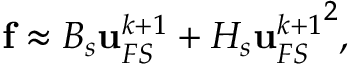Convert formula to latex. <formula><loc_0><loc_0><loc_500><loc_500>f \approx B _ { s } u _ { F S } ^ { k + 1 } + H _ { s } { u _ { F S } ^ { k + 1 } } ^ { 2 } ,</formula> 